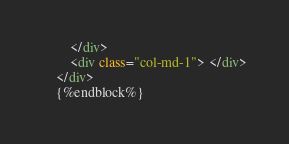Convert code to text. <code><loc_0><loc_0><loc_500><loc_500><_HTML_>        </div>
        <div class="col-md-1"> </div>
    </div>
    {%endblock%}</code> 